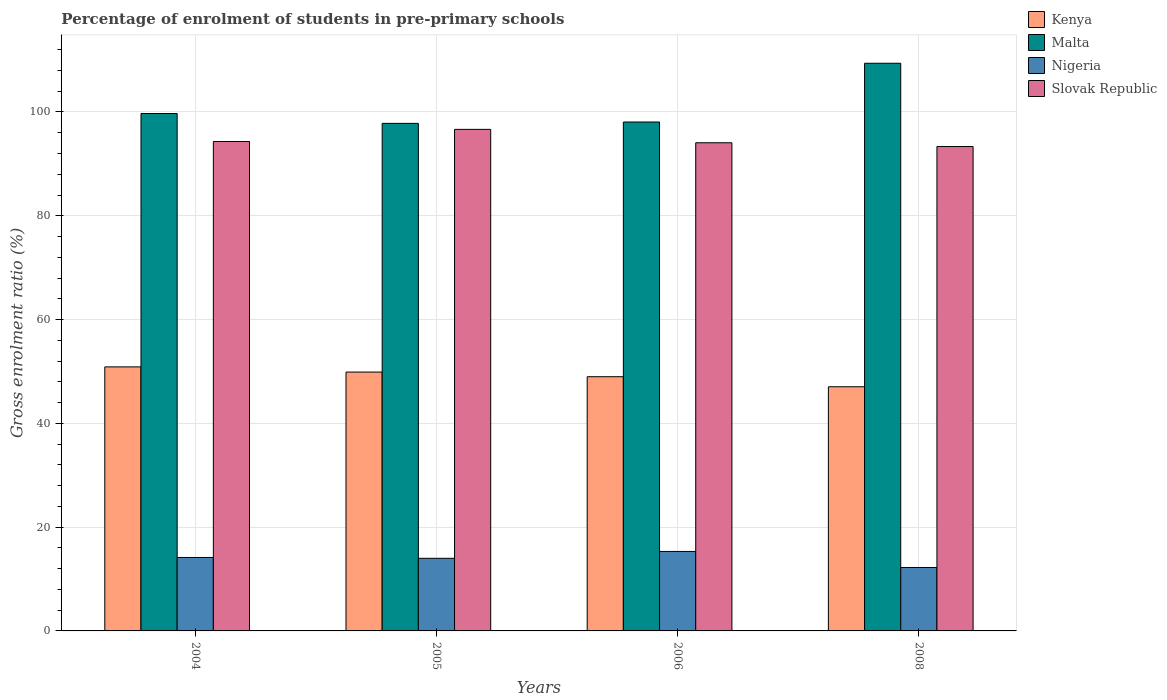How many bars are there on the 4th tick from the right?
Ensure brevity in your answer.  4. In how many cases, is the number of bars for a given year not equal to the number of legend labels?
Offer a terse response. 0. What is the percentage of students enrolled in pre-primary schools in Slovak Republic in 2005?
Provide a succinct answer. 96.65. Across all years, what is the maximum percentage of students enrolled in pre-primary schools in Kenya?
Your answer should be compact. 50.88. Across all years, what is the minimum percentage of students enrolled in pre-primary schools in Nigeria?
Offer a terse response. 12.22. In which year was the percentage of students enrolled in pre-primary schools in Slovak Republic maximum?
Ensure brevity in your answer.  2005. What is the total percentage of students enrolled in pre-primary schools in Malta in the graph?
Keep it short and to the point. 404.96. What is the difference between the percentage of students enrolled in pre-primary schools in Nigeria in 2004 and that in 2008?
Make the answer very short. 1.93. What is the difference between the percentage of students enrolled in pre-primary schools in Slovak Republic in 2008 and the percentage of students enrolled in pre-primary schools in Nigeria in 2004?
Give a very brief answer. 79.19. What is the average percentage of students enrolled in pre-primary schools in Kenya per year?
Your response must be concise. 49.2. In the year 2006, what is the difference between the percentage of students enrolled in pre-primary schools in Kenya and percentage of students enrolled in pre-primary schools in Malta?
Your answer should be very brief. -49.08. What is the ratio of the percentage of students enrolled in pre-primary schools in Kenya in 2004 to that in 2008?
Provide a succinct answer. 1.08. Is the percentage of students enrolled in pre-primary schools in Nigeria in 2006 less than that in 2008?
Ensure brevity in your answer.  No. Is the difference between the percentage of students enrolled in pre-primary schools in Kenya in 2005 and 2008 greater than the difference between the percentage of students enrolled in pre-primary schools in Malta in 2005 and 2008?
Make the answer very short. Yes. What is the difference between the highest and the second highest percentage of students enrolled in pre-primary schools in Slovak Republic?
Offer a terse response. 2.34. What is the difference between the highest and the lowest percentage of students enrolled in pre-primary schools in Malta?
Provide a short and direct response. 11.58. Is the sum of the percentage of students enrolled in pre-primary schools in Malta in 2004 and 2006 greater than the maximum percentage of students enrolled in pre-primary schools in Kenya across all years?
Ensure brevity in your answer.  Yes. Is it the case that in every year, the sum of the percentage of students enrolled in pre-primary schools in Kenya and percentage of students enrolled in pre-primary schools in Nigeria is greater than the sum of percentage of students enrolled in pre-primary schools in Malta and percentage of students enrolled in pre-primary schools in Slovak Republic?
Your answer should be very brief. No. What does the 2nd bar from the left in 2006 represents?
Make the answer very short. Malta. What does the 4th bar from the right in 2005 represents?
Provide a succinct answer. Kenya. How many bars are there?
Provide a succinct answer. 16. Are all the bars in the graph horizontal?
Offer a terse response. No. How many years are there in the graph?
Give a very brief answer. 4. What is the difference between two consecutive major ticks on the Y-axis?
Provide a short and direct response. 20. How many legend labels are there?
Make the answer very short. 4. How are the legend labels stacked?
Offer a terse response. Vertical. What is the title of the graph?
Offer a terse response. Percentage of enrolment of students in pre-primary schools. Does "Sao Tome and Principe" appear as one of the legend labels in the graph?
Make the answer very short. No. What is the label or title of the X-axis?
Offer a very short reply. Years. What is the Gross enrolment ratio (%) of Kenya in 2004?
Your answer should be compact. 50.88. What is the Gross enrolment ratio (%) in Malta in 2004?
Your response must be concise. 99.71. What is the Gross enrolment ratio (%) in Nigeria in 2004?
Provide a short and direct response. 14.15. What is the Gross enrolment ratio (%) of Slovak Republic in 2004?
Give a very brief answer. 94.31. What is the Gross enrolment ratio (%) of Kenya in 2005?
Give a very brief answer. 49.88. What is the Gross enrolment ratio (%) of Malta in 2005?
Your response must be concise. 97.8. What is the Gross enrolment ratio (%) in Nigeria in 2005?
Your response must be concise. 13.99. What is the Gross enrolment ratio (%) in Slovak Republic in 2005?
Provide a short and direct response. 96.65. What is the Gross enrolment ratio (%) in Kenya in 2006?
Your response must be concise. 48.99. What is the Gross enrolment ratio (%) of Malta in 2006?
Make the answer very short. 98.07. What is the Gross enrolment ratio (%) of Nigeria in 2006?
Your response must be concise. 15.32. What is the Gross enrolment ratio (%) of Slovak Republic in 2006?
Offer a very short reply. 94.07. What is the Gross enrolment ratio (%) in Kenya in 2008?
Offer a terse response. 47.05. What is the Gross enrolment ratio (%) in Malta in 2008?
Your answer should be compact. 109.39. What is the Gross enrolment ratio (%) in Nigeria in 2008?
Provide a succinct answer. 12.22. What is the Gross enrolment ratio (%) in Slovak Republic in 2008?
Your response must be concise. 93.34. Across all years, what is the maximum Gross enrolment ratio (%) in Kenya?
Make the answer very short. 50.88. Across all years, what is the maximum Gross enrolment ratio (%) in Malta?
Keep it short and to the point. 109.39. Across all years, what is the maximum Gross enrolment ratio (%) in Nigeria?
Your response must be concise. 15.32. Across all years, what is the maximum Gross enrolment ratio (%) in Slovak Republic?
Provide a short and direct response. 96.65. Across all years, what is the minimum Gross enrolment ratio (%) in Kenya?
Your response must be concise. 47.05. Across all years, what is the minimum Gross enrolment ratio (%) in Malta?
Provide a succinct answer. 97.8. Across all years, what is the minimum Gross enrolment ratio (%) in Nigeria?
Give a very brief answer. 12.22. Across all years, what is the minimum Gross enrolment ratio (%) of Slovak Republic?
Provide a succinct answer. 93.34. What is the total Gross enrolment ratio (%) in Kenya in the graph?
Offer a terse response. 196.8. What is the total Gross enrolment ratio (%) of Malta in the graph?
Provide a succinct answer. 404.96. What is the total Gross enrolment ratio (%) in Nigeria in the graph?
Ensure brevity in your answer.  55.68. What is the total Gross enrolment ratio (%) in Slovak Republic in the graph?
Provide a succinct answer. 378.36. What is the difference between the Gross enrolment ratio (%) of Malta in 2004 and that in 2005?
Provide a succinct answer. 1.9. What is the difference between the Gross enrolment ratio (%) of Nigeria in 2004 and that in 2005?
Your answer should be compact. 0.16. What is the difference between the Gross enrolment ratio (%) in Slovak Republic in 2004 and that in 2005?
Keep it short and to the point. -2.34. What is the difference between the Gross enrolment ratio (%) of Kenya in 2004 and that in 2006?
Your answer should be very brief. 1.89. What is the difference between the Gross enrolment ratio (%) of Malta in 2004 and that in 2006?
Provide a short and direct response. 1.64. What is the difference between the Gross enrolment ratio (%) of Nigeria in 2004 and that in 2006?
Ensure brevity in your answer.  -1.16. What is the difference between the Gross enrolment ratio (%) in Slovak Republic in 2004 and that in 2006?
Keep it short and to the point. 0.24. What is the difference between the Gross enrolment ratio (%) in Kenya in 2004 and that in 2008?
Your answer should be compact. 3.83. What is the difference between the Gross enrolment ratio (%) in Malta in 2004 and that in 2008?
Your answer should be very brief. -9.68. What is the difference between the Gross enrolment ratio (%) of Nigeria in 2004 and that in 2008?
Keep it short and to the point. 1.93. What is the difference between the Gross enrolment ratio (%) in Slovak Republic in 2004 and that in 2008?
Keep it short and to the point. 0.97. What is the difference between the Gross enrolment ratio (%) in Kenya in 2005 and that in 2006?
Ensure brevity in your answer.  0.89. What is the difference between the Gross enrolment ratio (%) in Malta in 2005 and that in 2006?
Offer a terse response. -0.26. What is the difference between the Gross enrolment ratio (%) in Nigeria in 2005 and that in 2006?
Ensure brevity in your answer.  -1.32. What is the difference between the Gross enrolment ratio (%) in Slovak Republic in 2005 and that in 2006?
Keep it short and to the point. 2.58. What is the difference between the Gross enrolment ratio (%) of Kenya in 2005 and that in 2008?
Give a very brief answer. 2.83. What is the difference between the Gross enrolment ratio (%) of Malta in 2005 and that in 2008?
Offer a very short reply. -11.58. What is the difference between the Gross enrolment ratio (%) of Nigeria in 2005 and that in 2008?
Offer a terse response. 1.77. What is the difference between the Gross enrolment ratio (%) in Slovak Republic in 2005 and that in 2008?
Offer a terse response. 3.31. What is the difference between the Gross enrolment ratio (%) of Kenya in 2006 and that in 2008?
Ensure brevity in your answer.  1.93. What is the difference between the Gross enrolment ratio (%) of Malta in 2006 and that in 2008?
Provide a succinct answer. -11.32. What is the difference between the Gross enrolment ratio (%) in Nigeria in 2006 and that in 2008?
Give a very brief answer. 3.09. What is the difference between the Gross enrolment ratio (%) in Slovak Republic in 2006 and that in 2008?
Give a very brief answer. 0.73. What is the difference between the Gross enrolment ratio (%) of Kenya in 2004 and the Gross enrolment ratio (%) of Malta in 2005?
Ensure brevity in your answer.  -46.92. What is the difference between the Gross enrolment ratio (%) of Kenya in 2004 and the Gross enrolment ratio (%) of Nigeria in 2005?
Keep it short and to the point. 36.89. What is the difference between the Gross enrolment ratio (%) of Kenya in 2004 and the Gross enrolment ratio (%) of Slovak Republic in 2005?
Your answer should be compact. -45.77. What is the difference between the Gross enrolment ratio (%) in Malta in 2004 and the Gross enrolment ratio (%) in Nigeria in 2005?
Provide a short and direct response. 85.71. What is the difference between the Gross enrolment ratio (%) of Malta in 2004 and the Gross enrolment ratio (%) of Slovak Republic in 2005?
Your response must be concise. 3.06. What is the difference between the Gross enrolment ratio (%) in Nigeria in 2004 and the Gross enrolment ratio (%) in Slovak Republic in 2005?
Give a very brief answer. -82.49. What is the difference between the Gross enrolment ratio (%) of Kenya in 2004 and the Gross enrolment ratio (%) of Malta in 2006?
Keep it short and to the point. -47.19. What is the difference between the Gross enrolment ratio (%) of Kenya in 2004 and the Gross enrolment ratio (%) of Nigeria in 2006?
Offer a terse response. 35.56. What is the difference between the Gross enrolment ratio (%) in Kenya in 2004 and the Gross enrolment ratio (%) in Slovak Republic in 2006?
Make the answer very short. -43.19. What is the difference between the Gross enrolment ratio (%) of Malta in 2004 and the Gross enrolment ratio (%) of Nigeria in 2006?
Your response must be concise. 84.39. What is the difference between the Gross enrolment ratio (%) of Malta in 2004 and the Gross enrolment ratio (%) of Slovak Republic in 2006?
Ensure brevity in your answer.  5.64. What is the difference between the Gross enrolment ratio (%) in Nigeria in 2004 and the Gross enrolment ratio (%) in Slovak Republic in 2006?
Your answer should be very brief. -79.91. What is the difference between the Gross enrolment ratio (%) in Kenya in 2004 and the Gross enrolment ratio (%) in Malta in 2008?
Keep it short and to the point. -58.51. What is the difference between the Gross enrolment ratio (%) of Kenya in 2004 and the Gross enrolment ratio (%) of Nigeria in 2008?
Offer a terse response. 38.66. What is the difference between the Gross enrolment ratio (%) in Kenya in 2004 and the Gross enrolment ratio (%) in Slovak Republic in 2008?
Offer a terse response. -42.46. What is the difference between the Gross enrolment ratio (%) in Malta in 2004 and the Gross enrolment ratio (%) in Nigeria in 2008?
Your response must be concise. 87.48. What is the difference between the Gross enrolment ratio (%) of Malta in 2004 and the Gross enrolment ratio (%) of Slovak Republic in 2008?
Provide a short and direct response. 6.37. What is the difference between the Gross enrolment ratio (%) of Nigeria in 2004 and the Gross enrolment ratio (%) of Slovak Republic in 2008?
Keep it short and to the point. -79.19. What is the difference between the Gross enrolment ratio (%) in Kenya in 2005 and the Gross enrolment ratio (%) in Malta in 2006?
Ensure brevity in your answer.  -48.19. What is the difference between the Gross enrolment ratio (%) of Kenya in 2005 and the Gross enrolment ratio (%) of Nigeria in 2006?
Give a very brief answer. 34.56. What is the difference between the Gross enrolment ratio (%) in Kenya in 2005 and the Gross enrolment ratio (%) in Slovak Republic in 2006?
Your response must be concise. -44.19. What is the difference between the Gross enrolment ratio (%) of Malta in 2005 and the Gross enrolment ratio (%) of Nigeria in 2006?
Provide a short and direct response. 82.49. What is the difference between the Gross enrolment ratio (%) of Malta in 2005 and the Gross enrolment ratio (%) of Slovak Republic in 2006?
Provide a succinct answer. 3.74. What is the difference between the Gross enrolment ratio (%) in Nigeria in 2005 and the Gross enrolment ratio (%) in Slovak Republic in 2006?
Keep it short and to the point. -80.07. What is the difference between the Gross enrolment ratio (%) in Kenya in 2005 and the Gross enrolment ratio (%) in Malta in 2008?
Ensure brevity in your answer.  -59.51. What is the difference between the Gross enrolment ratio (%) of Kenya in 2005 and the Gross enrolment ratio (%) of Nigeria in 2008?
Your response must be concise. 37.66. What is the difference between the Gross enrolment ratio (%) of Kenya in 2005 and the Gross enrolment ratio (%) of Slovak Republic in 2008?
Offer a terse response. -43.46. What is the difference between the Gross enrolment ratio (%) in Malta in 2005 and the Gross enrolment ratio (%) in Nigeria in 2008?
Offer a very short reply. 85.58. What is the difference between the Gross enrolment ratio (%) in Malta in 2005 and the Gross enrolment ratio (%) in Slovak Republic in 2008?
Your answer should be very brief. 4.46. What is the difference between the Gross enrolment ratio (%) in Nigeria in 2005 and the Gross enrolment ratio (%) in Slovak Republic in 2008?
Offer a very short reply. -79.35. What is the difference between the Gross enrolment ratio (%) of Kenya in 2006 and the Gross enrolment ratio (%) of Malta in 2008?
Provide a short and direct response. -60.4. What is the difference between the Gross enrolment ratio (%) in Kenya in 2006 and the Gross enrolment ratio (%) in Nigeria in 2008?
Your response must be concise. 36.76. What is the difference between the Gross enrolment ratio (%) of Kenya in 2006 and the Gross enrolment ratio (%) of Slovak Republic in 2008?
Provide a succinct answer. -44.35. What is the difference between the Gross enrolment ratio (%) in Malta in 2006 and the Gross enrolment ratio (%) in Nigeria in 2008?
Your response must be concise. 85.84. What is the difference between the Gross enrolment ratio (%) in Malta in 2006 and the Gross enrolment ratio (%) in Slovak Republic in 2008?
Make the answer very short. 4.73. What is the difference between the Gross enrolment ratio (%) in Nigeria in 2006 and the Gross enrolment ratio (%) in Slovak Republic in 2008?
Give a very brief answer. -78.02. What is the average Gross enrolment ratio (%) of Kenya per year?
Offer a very short reply. 49.2. What is the average Gross enrolment ratio (%) in Malta per year?
Provide a short and direct response. 101.24. What is the average Gross enrolment ratio (%) of Nigeria per year?
Provide a succinct answer. 13.92. What is the average Gross enrolment ratio (%) of Slovak Republic per year?
Provide a succinct answer. 94.59. In the year 2004, what is the difference between the Gross enrolment ratio (%) in Kenya and Gross enrolment ratio (%) in Malta?
Keep it short and to the point. -48.83. In the year 2004, what is the difference between the Gross enrolment ratio (%) of Kenya and Gross enrolment ratio (%) of Nigeria?
Offer a terse response. 36.73. In the year 2004, what is the difference between the Gross enrolment ratio (%) of Kenya and Gross enrolment ratio (%) of Slovak Republic?
Make the answer very short. -43.43. In the year 2004, what is the difference between the Gross enrolment ratio (%) in Malta and Gross enrolment ratio (%) in Nigeria?
Provide a short and direct response. 85.55. In the year 2004, what is the difference between the Gross enrolment ratio (%) of Malta and Gross enrolment ratio (%) of Slovak Republic?
Make the answer very short. 5.4. In the year 2004, what is the difference between the Gross enrolment ratio (%) of Nigeria and Gross enrolment ratio (%) of Slovak Republic?
Keep it short and to the point. -80.16. In the year 2005, what is the difference between the Gross enrolment ratio (%) of Kenya and Gross enrolment ratio (%) of Malta?
Ensure brevity in your answer.  -47.93. In the year 2005, what is the difference between the Gross enrolment ratio (%) of Kenya and Gross enrolment ratio (%) of Nigeria?
Give a very brief answer. 35.89. In the year 2005, what is the difference between the Gross enrolment ratio (%) of Kenya and Gross enrolment ratio (%) of Slovak Republic?
Your answer should be very brief. -46.77. In the year 2005, what is the difference between the Gross enrolment ratio (%) in Malta and Gross enrolment ratio (%) in Nigeria?
Give a very brief answer. 83.81. In the year 2005, what is the difference between the Gross enrolment ratio (%) in Malta and Gross enrolment ratio (%) in Slovak Republic?
Offer a terse response. 1.16. In the year 2005, what is the difference between the Gross enrolment ratio (%) in Nigeria and Gross enrolment ratio (%) in Slovak Republic?
Offer a terse response. -82.65. In the year 2006, what is the difference between the Gross enrolment ratio (%) of Kenya and Gross enrolment ratio (%) of Malta?
Your answer should be very brief. -49.08. In the year 2006, what is the difference between the Gross enrolment ratio (%) in Kenya and Gross enrolment ratio (%) in Nigeria?
Provide a succinct answer. 33.67. In the year 2006, what is the difference between the Gross enrolment ratio (%) in Kenya and Gross enrolment ratio (%) in Slovak Republic?
Keep it short and to the point. -45.08. In the year 2006, what is the difference between the Gross enrolment ratio (%) of Malta and Gross enrolment ratio (%) of Nigeria?
Offer a terse response. 82.75. In the year 2006, what is the difference between the Gross enrolment ratio (%) of Malta and Gross enrolment ratio (%) of Slovak Republic?
Ensure brevity in your answer.  4. In the year 2006, what is the difference between the Gross enrolment ratio (%) of Nigeria and Gross enrolment ratio (%) of Slovak Republic?
Offer a very short reply. -78.75. In the year 2008, what is the difference between the Gross enrolment ratio (%) of Kenya and Gross enrolment ratio (%) of Malta?
Provide a short and direct response. -62.34. In the year 2008, what is the difference between the Gross enrolment ratio (%) of Kenya and Gross enrolment ratio (%) of Nigeria?
Offer a very short reply. 34.83. In the year 2008, what is the difference between the Gross enrolment ratio (%) in Kenya and Gross enrolment ratio (%) in Slovak Republic?
Keep it short and to the point. -46.29. In the year 2008, what is the difference between the Gross enrolment ratio (%) in Malta and Gross enrolment ratio (%) in Nigeria?
Provide a short and direct response. 97.17. In the year 2008, what is the difference between the Gross enrolment ratio (%) in Malta and Gross enrolment ratio (%) in Slovak Republic?
Provide a short and direct response. 16.05. In the year 2008, what is the difference between the Gross enrolment ratio (%) of Nigeria and Gross enrolment ratio (%) of Slovak Republic?
Offer a terse response. -81.12. What is the ratio of the Gross enrolment ratio (%) of Kenya in 2004 to that in 2005?
Keep it short and to the point. 1.02. What is the ratio of the Gross enrolment ratio (%) of Malta in 2004 to that in 2005?
Offer a very short reply. 1.02. What is the ratio of the Gross enrolment ratio (%) in Nigeria in 2004 to that in 2005?
Provide a short and direct response. 1.01. What is the ratio of the Gross enrolment ratio (%) in Slovak Republic in 2004 to that in 2005?
Ensure brevity in your answer.  0.98. What is the ratio of the Gross enrolment ratio (%) in Kenya in 2004 to that in 2006?
Ensure brevity in your answer.  1.04. What is the ratio of the Gross enrolment ratio (%) in Malta in 2004 to that in 2006?
Keep it short and to the point. 1.02. What is the ratio of the Gross enrolment ratio (%) of Nigeria in 2004 to that in 2006?
Provide a succinct answer. 0.92. What is the ratio of the Gross enrolment ratio (%) of Slovak Republic in 2004 to that in 2006?
Keep it short and to the point. 1. What is the ratio of the Gross enrolment ratio (%) of Kenya in 2004 to that in 2008?
Ensure brevity in your answer.  1.08. What is the ratio of the Gross enrolment ratio (%) of Malta in 2004 to that in 2008?
Keep it short and to the point. 0.91. What is the ratio of the Gross enrolment ratio (%) in Nigeria in 2004 to that in 2008?
Offer a very short reply. 1.16. What is the ratio of the Gross enrolment ratio (%) of Slovak Republic in 2004 to that in 2008?
Your answer should be compact. 1.01. What is the ratio of the Gross enrolment ratio (%) of Kenya in 2005 to that in 2006?
Give a very brief answer. 1.02. What is the ratio of the Gross enrolment ratio (%) in Malta in 2005 to that in 2006?
Ensure brevity in your answer.  1. What is the ratio of the Gross enrolment ratio (%) of Nigeria in 2005 to that in 2006?
Provide a short and direct response. 0.91. What is the ratio of the Gross enrolment ratio (%) in Slovak Republic in 2005 to that in 2006?
Ensure brevity in your answer.  1.03. What is the ratio of the Gross enrolment ratio (%) of Kenya in 2005 to that in 2008?
Provide a short and direct response. 1.06. What is the ratio of the Gross enrolment ratio (%) of Malta in 2005 to that in 2008?
Provide a short and direct response. 0.89. What is the ratio of the Gross enrolment ratio (%) of Nigeria in 2005 to that in 2008?
Ensure brevity in your answer.  1.14. What is the ratio of the Gross enrolment ratio (%) in Slovak Republic in 2005 to that in 2008?
Provide a succinct answer. 1.04. What is the ratio of the Gross enrolment ratio (%) of Kenya in 2006 to that in 2008?
Your answer should be very brief. 1.04. What is the ratio of the Gross enrolment ratio (%) of Malta in 2006 to that in 2008?
Make the answer very short. 0.9. What is the ratio of the Gross enrolment ratio (%) of Nigeria in 2006 to that in 2008?
Give a very brief answer. 1.25. What is the ratio of the Gross enrolment ratio (%) of Slovak Republic in 2006 to that in 2008?
Provide a succinct answer. 1.01. What is the difference between the highest and the second highest Gross enrolment ratio (%) of Kenya?
Offer a terse response. 1. What is the difference between the highest and the second highest Gross enrolment ratio (%) of Malta?
Ensure brevity in your answer.  9.68. What is the difference between the highest and the second highest Gross enrolment ratio (%) of Nigeria?
Ensure brevity in your answer.  1.16. What is the difference between the highest and the second highest Gross enrolment ratio (%) in Slovak Republic?
Keep it short and to the point. 2.34. What is the difference between the highest and the lowest Gross enrolment ratio (%) of Kenya?
Your answer should be very brief. 3.83. What is the difference between the highest and the lowest Gross enrolment ratio (%) in Malta?
Provide a succinct answer. 11.58. What is the difference between the highest and the lowest Gross enrolment ratio (%) of Nigeria?
Your answer should be compact. 3.09. What is the difference between the highest and the lowest Gross enrolment ratio (%) of Slovak Republic?
Keep it short and to the point. 3.31. 